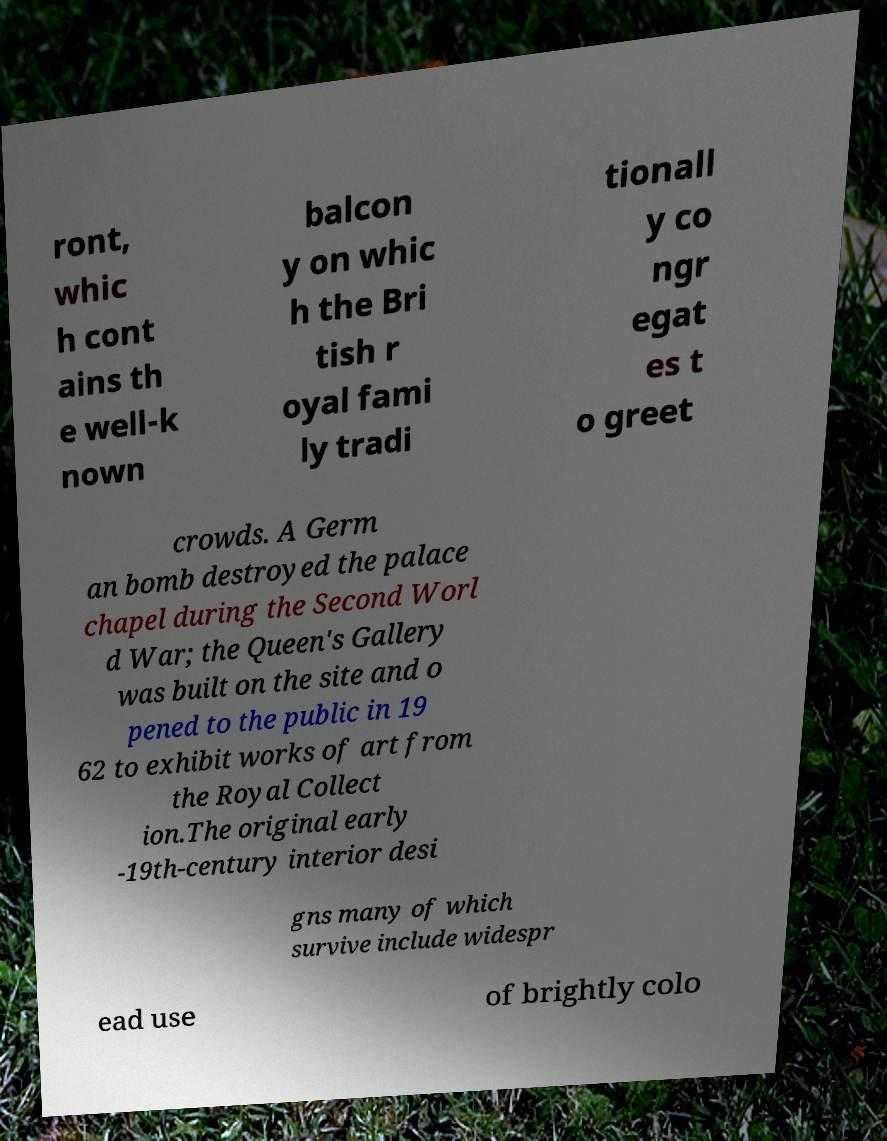Please read and relay the text visible in this image. What does it say? ront, whic h cont ains th e well-k nown balcon y on whic h the Bri tish r oyal fami ly tradi tionall y co ngr egat es t o greet crowds. A Germ an bomb destroyed the palace chapel during the Second Worl d War; the Queen's Gallery was built on the site and o pened to the public in 19 62 to exhibit works of art from the Royal Collect ion.The original early -19th-century interior desi gns many of which survive include widespr ead use of brightly colo 